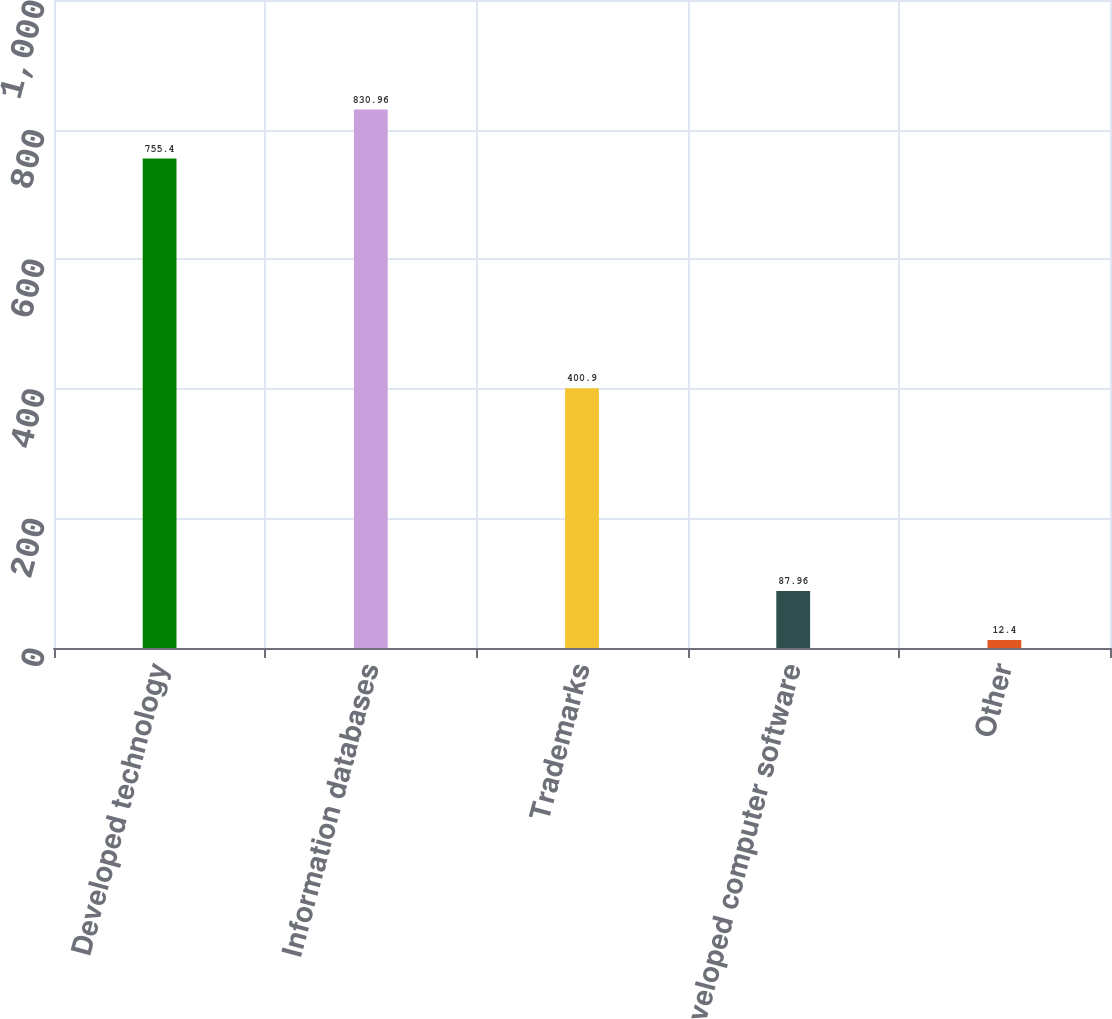Convert chart to OTSL. <chart><loc_0><loc_0><loc_500><loc_500><bar_chart><fcel>Developed technology<fcel>Information databases<fcel>Trademarks<fcel>Developed computer software<fcel>Other<nl><fcel>755.4<fcel>830.96<fcel>400.9<fcel>87.96<fcel>12.4<nl></chart> 